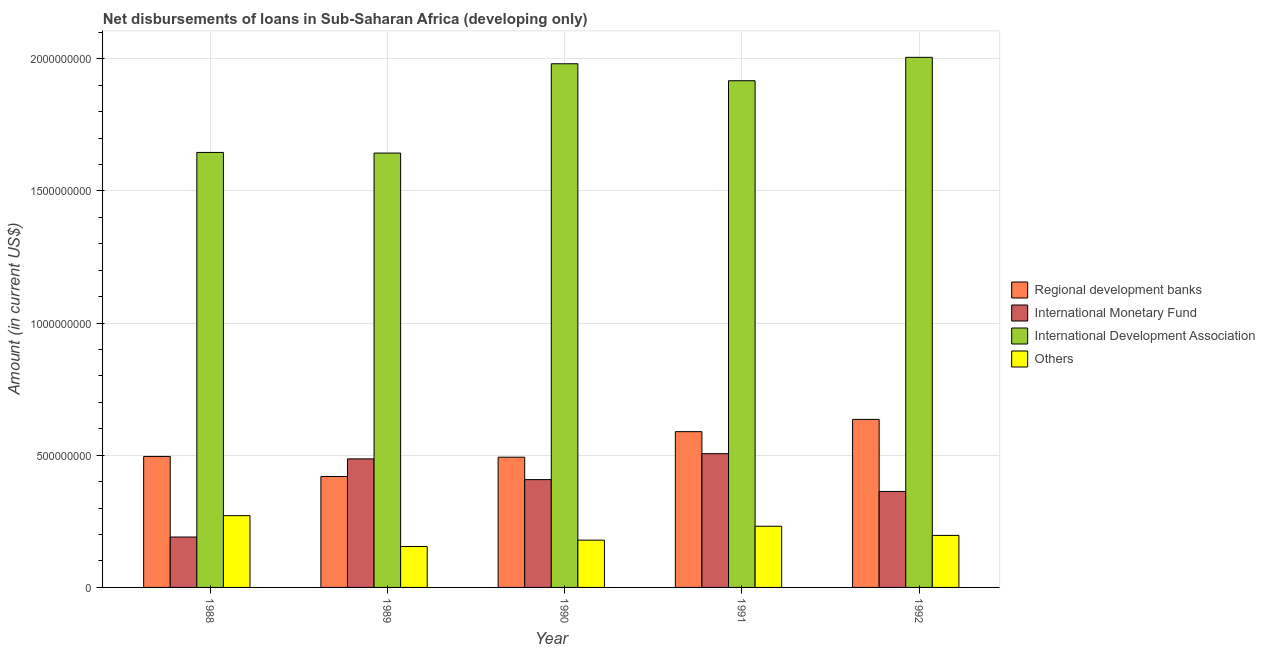How many different coloured bars are there?
Give a very brief answer. 4. How many groups of bars are there?
Give a very brief answer. 5. Are the number of bars per tick equal to the number of legend labels?
Provide a short and direct response. Yes. Are the number of bars on each tick of the X-axis equal?
Your response must be concise. Yes. How many bars are there on the 4th tick from the right?
Your response must be concise. 4. What is the label of the 4th group of bars from the left?
Your answer should be compact. 1991. What is the amount of loan disimbursed by international development association in 1989?
Offer a terse response. 1.64e+09. Across all years, what is the maximum amount of loan disimbursed by other organisations?
Your response must be concise. 2.72e+08. Across all years, what is the minimum amount of loan disimbursed by international monetary fund?
Your answer should be compact. 1.91e+08. In which year was the amount of loan disimbursed by international development association minimum?
Your response must be concise. 1989. What is the total amount of loan disimbursed by international development association in the graph?
Provide a short and direct response. 9.19e+09. What is the difference between the amount of loan disimbursed by international development association in 1989 and that in 1991?
Provide a short and direct response. -2.74e+08. What is the difference between the amount of loan disimbursed by international monetary fund in 1989 and the amount of loan disimbursed by regional development banks in 1988?
Give a very brief answer. 2.96e+08. What is the average amount of loan disimbursed by other organisations per year?
Offer a terse response. 2.07e+08. In how many years, is the amount of loan disimbursed by international development association greater than 600000000 US$?
Your response must be concise. 5. What is the ratio of the amount of loan disimbursed by international development association in 1989 to that in 1990?
Ensure brevity in your answer.  0.83. Is the amount of loan disimbursed by international development association in 1988 less than that in 1992?
Make the answer very short. Yes. Is the difference between the amount of loan disimbursed by regional development banks in 1990 and 1992 greater than the difference between the amount of loan disimbursed by international monetary fund in 1990 and 1992?
Keep it short and to the point. No. What is the difference between the highest and the second highest amount of loan disimbursed by regional development banks?
Provide a succinct answer. 4.63e+07. What is the difference between the highest and the lowest amount of loan disimbursed by regional development banks?
Ensure brevity in your answer.  2.16e+08. In how many years, is the amount of loan disimbursed by other organisations greater than the average amount of loan disimbursed by other organisations taken over all years?
Offer a very short reply. 2. Is it the case that in every year, the sum of the amount of loan disimbursed by international development association and amount of loan disimbursed by other organisations is greater than the sum of amount of loan disimbursed by international monetary fund and amount of loan disimbursed by regional development banks?
Give a very brief answer. Yes. What does the 3rd bar from the left in 1990 represents?
Make the answer very short. International Development Association. What does the 4th bar from the right in 1991 represents?
Your answer should be very brief. Regional development banks. Is it the case that in every year, the sum of the amount of loan disimbursed by regional development banks and amount of loan disimbursed by international monetary fund is greater than the amount of loan disimbursed by international development association?
Provide a succinct answer. No. How many bars are there?
Your answer should be very brief. 20. What is the difference between two consecutive major ticks on the Y-axis?
Keep it short and to the point. 5.00e+08. Does the graph contain any zero values?
Give a very brief answer. No. What is the title of the graph?
Offer a very short reply. Net disbursements of loans in Sub-Saharan Africa (developing only). What is the label or title of the X-axis?
Keep it short and to the point. Year. What is the label or title of the Y-axis?
Ensure brevity in your answer.  Amount (in current US$). What is the Amount (in current US$) in Regional development banks in 1988?
Provide a succinct answer. 4.96e+08. What is the Amount (in current US$) of International Monetary Fund in 1988?
Your answer should be compact. 1.91e+08. What is the Amount (in current US$) of International Development Association in 1988?
Offer a terse response. 1.65e+09. What is the Amount (in current US$) in Others in 1988?
Offer a very short reply. 2.72e+08. What is the Amount (in current US$) in Regional development banks in 1989?
Your response must be concise. 4.20e+08. What is the Amount (in current US$) of International Monetary Fund in 1989?
Offer a very short reply. 4.86e+08. What is the Amount (in current US$) in International Development Association in 1989?
Make the answer very short. 1.64e+09. What is the Amount (in current US$) in Others in 1989?
Ensure brevity in your answer.  1.55e+08. What is the Amount (in current US$) of Regional development banks in 1990?
Provide a succinct answer. 4.93e+08. What is the Amount (in current US$) of International Monetary Fund in 1990?
Provide a succinct answer. 4.08e+08. What is the Amount (in current US$) of International Development Association in 1990?
Ensure brevity in your answer.  1.98e+09. What is the Amount (in current US$) in Others in 1990?
Offer a very short reply. 1.79e+08. What is the Amount (in current US$) of Regional development banks in 1991?
Offer a terse response. 5.89e+08. What is the Amount (in current US$) in International Monetary Fund in 1991?
Ensure brevity in your answer.  5.06e+08. What is the Amount (in current US$) in International Development Association in 1991?
Your response must be concise. 1.92e+09. What is the Amount (in current US$) in Others in 1991?
Provide a short and direct response. 2.31e+08. What is the Amount (in current US$) of Regional development banks in 1992?
Give a very brief answer. 6.36e+08. What is the Amount (in current US$) in International Monetary Fund in 1992?
Offer a very short reply. 3.63e+08. What is the Amount (in current US$) in International Development Association in 1992?
Your answer should be very brief. 2.01e+09. What is the Amount (in current US$) of Others in 1992?
Ensure brevity in your answer.  1.97e+08. Across all years, what is the maximum Amount (in current US$) in Regional development banks?
Offer a terse response. 6.36e+08. Across all years, what is the maximum Amount (in current US$) of International Monetary Fund?
Provide a succinct answer. 5.06e+08. Across all years, what is the maximum Amount (in current US$) of International Development Association?
Your answer should be very brief. 2.01e+09. Across all years, what is the maximum Amount (in current US$) of Others?
Your response must be concise. 2.72e+08. Across all years, what is the minimum Amount (in current US$) of Regional development banks?
Ensure brevity in your answer.  4.20e+08. Across all years, what is the minimum Amount (in current US$) in International Monetary Fund?
Offer a terse response. 1.91e+08. Across all years, what is the minimum Amount (in current US$) of International Development Association?
Make the answer very short. 1.64e+09. Across all years, what is the minimum Amount (in current US$) in Others?
Provide a succinct answer. 1.55e+08. What is the total Amount (in current US$) in Regional development banks in the graph?
Your response must be concise. 2.63e+09. What is the total Amount (in current US$) of International Monetary Fund in the graph?
Give a very brief answer. 1.95e+09. What is the total Amount (in current US$) of International Development Association in the graph?
Keep it short and to the point. 9.19e+09. What is the total Amount (in current US$) of Others in the graph?
Your answer should be compact. 1.03e+09. What is the difference between the Amount (in current US$) of Regional development banks in 1988 and that in 1989?
Offer a terse response. 7.58e+07. What is the difference between the Amount (in current US$) of International Monetary Fund in 1988 and that in 1989?
Make the answer very short. -2.96e+08. What is the difference between the Amount (in current US$) in International Development Association in 1988 and that in 1989?
Offer a terse response. 2.42e+06. What is the difference between the Amount (in current US$) in Others in 1988 and that in 1989?
Keep it short and to the point. 1.17e+08. What is the difference between the Amount (in current US$) in Regional development banks in 1988 and that in 1990?
Your answer should be very brief. 2.80e+06. What is the difference between the Amount (in current US$) in International Monetary Fund in 1988 and that in 1990?
Give a very brief answer. -2.17e+08. What is the difference between the Amount (in current US$) of International Development Association in 1988 and that in 1990?
Offer a very short reply. -3.35e+08. What is the difference between the Amount (in current US$) in Others in 1988 and that in 1990?
Keep it short and to the point. 9.27e+07. What is the difference between the Amount (in current US$) of Regional development banks in 1988 and that in 1991?
Provide a succinct answer. -9.39e+07. What is the difference between the Amount (in current US$) of International Monetary Fund in 1988 and that in 1991?
Your answer should be very brief. -3.15e+08. What is the difference between the Amount (in current US$) in International Development Association in 1988 and that in 1991?
Give a very brief answer. -2.71e+08. What is the difference between the Amount (in current US$) of Others in 1988 and that in 1991?
Offer a terse response. 4.02e+07. What is the difference between the Amount (in current US$) of Regional development banks in 1988 and that in 1992?
Your answer should be very brief. -1.40e+08. What is the difference between the Amount (in current US$) in International Monetary Fund in 1988 and that in 1992?
Make the answer very short. -1.72e+08. What is the difference between the Amount (in current US$) in International Development Association in 1988 and that in 1992?
Your answer should be very brief. -3.60e+08. What is the difference between the Amount (in current US$) of Others in 1988 and that in 1992?
Offer a terse response. 7.48e+07. What is the difference between the Amount (in current US$) of Regional development banks in 1989 and that in 1990?
Offer a very short reply. -7.30e+07. What is the difference between the Amount (in current US$) of International Monetary Fund in 1989 and that in 1990?
Your answer should be very brief. 7.84e+07. What is the difference between the Amount (in current US$) of International Development Association in 1989 and that in 1990?
Your response must be concise. -3.38e+08. What is the difference between the Amount (in current US$) in Others in 1989 and that in 1990?
Provide a succinct answer. -2.41e+07. What is the difference between the Amount (in current US$) in Regional development banks in 1989 and that in 1991?
Offer a terse response. -1.70e+08. What is the difference between the Amount (in current US$) in International Monetary Fund in 1989 and that in 1991?
Provide a short and direct response. -1.97e+07. What is the difference between the Amount (in current US$) in International Development Association in 1989 and that in 1991?
Keep it short and to the point. -2.74e+08. What is the difference between the Amount (in current US$) in Others in 1989 and that in 1991?
Offer a terse response. -7.66e+07. What is the difference between the Amount (in current US$) of Regional development banks in 1989 and that in 1992?
Provide a succinct answer. -2.16e+08. What is the difference between the Amount (in current US$) in International Monetary Fund in 1989 and that in 1992?
Your response must be concise. 1.23e+08. What is the difference between the Amount (in current US$) of International Development Association in 1989 and that in 1992?
Your answer should be compact. -3.62e+08. What is the difference between the Amount (in current US$) of Others in 1989 and that in 1992?
Give a very brief answer. -4.20e+07. What is the difference between the Amount (in current US$) in Regional development banks in 1990 and that in 1991?
Offer a terse response. -9.66e+07. What is the difference between the Amount (in current US$) in International Monetary Fund in 1990 and that in 1991?
Ensure brevity in your answer.  -9.81e+07. What is the difference between the Amount (in current US$) of International Development Association in 1990 and that in 1991?
Keep it short and to the point. 6.42e+07. What is the difference between the Amount (in current US$) in Others in 1990 and that in 1991?
Your answer should be compact. -5.25e+07. What is the difference between the Amount (in current US$) of Regional development banks in 1990 and that in 1992?
Provide a succinct answer. -1.43e+08. What is the difference between the Amount (in current US$) in International Monetary Fund in 1990 and that in 1992?
Give a very brief answer. 4.48e+07. What is the difference between the Amount (in current US$) of International Development Association in 1990 and that in 1992?
Give a very brief answer. -2.44e+07. What is the difference between the Amount (in current US$) in Others in 1990 and that in 1992?
Provide a short and direct response. -1.79e+07. What is the difference between the Amount (in current US$) of Regional development banks in 1991 and that in 1992?
Your answer should be compact. -4.63e+07. What is the difference between the Amount (in current US$) in International Monetary Fund in 1991 and that in 1992?
Your answer should be compact. 1.43e+08. What is the difference between the Amount (in current US$) in International Development Association in 1991 and that in 1992?
Your answer should be very brief. -8.85e+07. What is the difference between the Amount (in current US$) in Others in 1991 and that in 1992?
Your response must be concise. 3.46e+07. What is the difference between the Amount (in current US$) in Regional development banks in 1988 and the Amount (in current US$) in International Monetary Fund in 1989?
Your answer should be very brief. 9.19e+06. What is the difference between the Amount (in current US$) of Regional development banks in 1988 and the Amount (in current US$) of International Development Association in 1989?
Keep it short and to the point. -1.15e+09. What is the difference between the Amount (in current US$) in Regional development banks in 1988 and the Amount (in current US$) in Others in 1989?
Offer a very short reply. 3.41e+08. What is the difference between the Amount (in current US$) in International Monetary Fund in 1988 and the Amount (in current US$) in International Development Association in 1989?
Give a very brief answer. -1.45e+09. What is the difference between the Amount (in current US$) of International Monetary Fund in 1988 and the Amount (in current US$) of Others in 1989?
Provide a succinct answer. 3.59e+07. What is the difference between the Amount (in current US$) in International Development Association in 1988 and the Amount (in current US$) in Others in 1989?
Ensure brevity in your answer.  1.49e+09. What is the difference between the Amount (in current US$) of Regional development banks in 1988 and the Amount (in current US$) of International Monetary Fund in 1990?
Ensure brevity in your answer.  8.76e+07. What is the difference between the Amount (in current US$) of Regional development banks in 1988 and the Amount (in current US$) of International Development Association in 1990?
Provide a short and direct response. -1.49e+09. What is the difference between the Amount (in current US$) in Regional development banks in 1988 and the Amount (in current US$) in Others in 1990?
Give a very brief answer. 3.17e+08. What is the difference between the Amount (in current US$) of International Monetary Fund in 1988 and the Amount (in current US$) of International Development Association in 1990?
Offer a terse response. -1.79e+09. What is the difference between the Amount (in current US$) in International Monetary Fund in 1988 and the Amount (in current US$) in Others in 1990?
Keep it short and to the point. 1.18e+07. What is the difference between the Amount (in current US$) in International Development Association in 1988 and the Amount (in current US$) in Others in 1990?
Your answer should be compact. 1.47e+09. What is the difference between the Amount (in current US$) of Regional development banks in 1988 and the Amount (in current US$) of International Monetary Fund in 1991?
Give a very brief answer. -1.05e+07. What is the difference between the Amount (in current US$) in Regional development banks in 1988 and the Amount (in current US$) in International Development Association in 1991?
Your answer should be compact. -1.42e+09. What is the difference between the Amount (in current US$) of Regional development banks in 1988 and the Amount (in current US$) of Others in 1991?
Your answer should be compact. 2.64e+08. What is the difference between the Amount (in current US$) in International Monetary Fund in 1988 and the Amount (in current US$) in International Development Association in 1991?
Offer a terse response. -1.73e+09. What is the difference between the Amount (in current US$) in International Monetary Fund in 1988 and the Amount (in current US$) in Others in 1991?
Provide a short and direct response. -4.08e+07. What is the difference between the Amount (in current US$) of International Development Association in 1988 and the Amount (in current US$) of Others in 1991?
Your answer should be compact. 1.41e+09. What is the difference between the Amount (in current US$) in Regional development banks in 1988 and the Amount (in current US$) in International Monetary Fund in 1992?
Your response must be concise. 1.32e+08. What is the difference between the Amount (in current US$) in Regional development banks in 1988 and the Amount (in current US$) in International Development Association in 1992?
Give a very brief answer. -1.51e+09. What is the difference between the Amount (in current US$) of Regional development banks in 1988 and the Amount (in current US$) of Others in 1992?
Your answer should be compact. 2.99e+08. What is the difference between the Amount (in current US$) in International Monetary Fund in 1988 and the Amount (in current US$) in International Development Association in 1992?
Offer a very short reply. -1.81e+09. What is the difference between the Amount (in current US$) in International Monetary Fund in 1988 and the Amount (in current US$) in Others in 1992?
Offer a terse response. -6.17e+06. What is the difference between the Amount (in current US$) of International Development Association in 1988 and the Amount (in current US$) of Others in 1992?
Offer a very short reply. 1.45e+09. What is the difference between the Amount (in current US$) of Regional development banks in 1989 and the Amount (in current US$) of International Monetary Fund in 1990?
Ensure brevity in your answer.  1.18e+07. What is the difference between the Amount (in current US$) in Regional development banks in 1989 and the Amount (in current US$) in International Development Association in 1990?
Your answer should be compact. -1.56e+09. What is the difference between the Amount (in current US$) in Regional development banks in 1989 and the Amount (in current US$) in Others in 1990?
Your answer should be compact. 2.41e+08. What is the difference between the Amount (in current US$) in International Monetary Fund in 1989 and the Amount (in current US$) in International Development Association in 1990?
Give a very brief answer. -1.49e+09. What is the difference between the Amount (in current US$) in International Monetary Fund in 1989 and the Amount (in current US$) in Others in 1990?
Provide a succinct answer. 3.07e+08. What is the difference between the Amount (in current US$) in International Development Association in 1989 and the Amount (in current US$) in Others in 1990?
Your answer should be very brief. 1.46e+09. What is the difference between the Amount (in current US$) of Regional development banks in 1989 and the Amount (in current US$) of International Monetary Fund in 1991?
Your answer should be very brief. -8.63e+07. What is the difference between the Amount (in current US$) of Regional development banks in 1989 and the Amount (in current US$) of International Development Association in 1991?
Keep it short and to the point. -1.50e+09. What is the difference between the Amount (in current US$) in Regional development banks in 1989 and the Amount (in current US$) in Others in 1991?
Ensure brevity in your answer.  1.88e+08. What is the difference between the Amount (in current US$) of International Monetary Fund in 1989 and the Amount (in current US$) of International Development Association in 1991?
Provide a succinct answer. -1.43e+09. What is the difference between the Amount (in current US$) of International Monetary Fund in 1989 and the Amount (in current US$) of Others in 1991?
Offer a terse response. 2.55e+08. What is the difference between the Amount (in current US$) of International Development Association in 1989 and the Amount (in current US$) of Others in 1991?
Give a very brief answer. 1.41e+09. What is the difference between the Amount (in current US$) in Regional development banks in 1989 and the Amount (in current US$) in International Monetary Fund in 1992?
Provide a short and direct response. 5.66e+07. What is the difference between the Amount (in current US$) of Regional development banks in 1989 and the Amount (in current US$) of International Development Association in 1992?
Your answer should be compact. -1.59e+09. What is the difference between the Amount (in current US$) in Regional development banks in 1989 and the Amount (in current US$) in Others in 1992?
Ensure brevity in your answer.  2.23e+08. What is the difference between the Amount (in current US$) in International Monetary Fund in 1989 and the Amount (in current US$) in International Development Association in 1992?
Offer a terse response. -1.52e+09. What is the difference between the Amount (in current US$) of International Monetary Fund in 1989 and the Amount (in current US$) of Others in 1992?
Your answer should be compact. 2.90e+08. What is the difference between the Amount (in current US$) in International Development Association in 1989 and the Amount (in current US$) in Others in 1992?
Give a very brief answer. 1.45e+09. What is the difference between the Amount (in current US$) in Regional development banks in 1990 and the Amount (in current US$) in International Monetary Fund in 1991?
Provide a succinct answer. -1.33e+07. What is the difference between the Amount (in current US$) in Regional development banks in 1990 and the Amount (in current US$) in International Development Association in 1991?
Offer a terse response. -1.42e+09. What is the difference between the Amount (in current US$) of Regional development banks in 1990 and the Amount (in current US$) of Others in 1991?
Make the answer very short. 2.61e+08. What is the difference between the Amount (in current US$) of International Monetary Fund in 1990 and the Amount (in current US$) of International Development Association in 1991?
Keep it short and to the point. -1.51e+09. What is the difference between the Amount (in current US$) of International Monetary Fund in 1990 and the Amount (in current US$) of Others in 1991?
Give a very brief answer. 1.76e+08. What is the difference between the Amount (in current US$) of International Development Association in 1990 and the Amount (in current US$) of Others in 1991?
Your answer should be compact. 1.75e+09. What is the difference between the Amount (in current US$) in Regional development banks in 1990 and the Amount (in current US$) in International Monetary Fund in 1992?
Ensure brevity in your answer.  1.30e+08. What is the difference between the Amount (in current US$) in Regional development banks in 1990 and the Amount (in current US$) in International Development Association in 1992?
Ensure brevity in your answer.  -1.51e+09. What is the difference between the Amount (in current US$) of Regional development banks in 1990 and the Amount (in current US$) of Others in 1992?
Ensure brevity in your answer.  2.96e+08. What is the difference between the Amount (in current US$) of International Monetary Fund in 1990 and the Amount (in current US$) of International Development Association in 1992?
Your answer should be very brief. -1.60e+09. What is the difference between the Amount (in current US$) in International Monetary Fund in 1990 and the Amount (in current US$) in Others in 1992?
Offer a terse response. 2.11e+08. What is the difference between the Amount (in current US$) of International Development Association in 1990 and the Amount (in current US$) of Others in 1992?
Offer a terse response. 1.78e+09. What is the difference between the Amount (in current US$) in Regional development banks in 1991 and the Amount (in current US$) in International Monetary Fund in 1992?
Your answer should be compact. 2.26e+08. What is the difference between the Amount (in current US$) in Regional development banks in 1991 and the Amount (in current US$) in International Development Association in 1992?
Offer a terse response. -1.42e+09. What is the difference between the Amount (in current US$) in Regional development banks in 1991 and the Amount (in current US$) in Others in 1992?
Your answer should be compact. 3.93e+08. What is the difference between the Amount (in current US$) of International Monetary Fund in 1991 and the Amount (in current US$) of International Development Association in 1992?
Give a very brief answer. -1.50e+09. What is the difference between the Amount (in current US$) in International Monetary Fund in 1991 and the Amount (in current US$) in Others in 1992?
Your response must be concise. 3.09e+08. What is the difference between the Amount (in current US$) of International Development Association in 1991 and the Amount (in current US$) of Others in 1992?
Ensure brevity in your answer.  1.72e+09. What is the average Amount (in current US$) in Regional development banks per year?
Provide a succinct answer. 5.27e+08. What is the average Amount (in current US$) in International Monetary Fund per year?
Provide a short and direct response. 3.91e+08. What is the average Amount (in current US$) of International Development Association per year?
Offer a terse response. 1.84e+09. What is the average Amount (in current US$) of Others per year?
Provide a short and direct response. 2.07e+08. In the year 1988, what is the difference between the Amount (in current US$) of Regional development banks and Amount (in current US$) of International Monetary Fund?
Give a very brief answer. 3.05e+08. In the year 1988, what is the difference between the Amount (in current US$) in Regional development banks and Amount (in current US$) in International Development Association?
Your answer should be compact. -1.15e+09. In the year 1988, what is the difference between the Amount (in current US$) of Regional development banks and Amount (in current US$) of Others?
Your answer should be very brief. 2.24e+08. In the year 1988, what is the difference between the Amount (in current US$) in International Monetary Fund and Amount (in current US$) in International Development Association?
Offer a very short reply. -1.46e+09. In the year 1988, what is the difference between the Amount (in current US$) of International Monetary Fund and Amount (in current US$) of Others?
Provide a succinct answer. -8.09e+07. In the year 1988, what is the difference between the Amount (in current US$) in International Development Association and Amount (in current US$) in Others?
Ensure brevity in your answer.  1.37e+09. In the year 1989, what is the difference between the Amount (in current US$) of Regional development banks and Amount (in current US$) of International Monetary Fund?
Provide a short and direct response. -6.66e+07. In the year 1989, what is the difference between the Amount (in current US$) in Regional development banks and Amount (in current US$) in International Development Association?
Your answer should be compact. -1.22e+09. In the year 1989, what is the difference between the Amount (in current US$) of Regional development banks and Amount (in current US$) of Others?
Offer a very short reply. 2.65e+08. In the year 1989, what is the difference between the Amount (in current US$) in International Monetary Fund and Amount (in current US$) in International Development Association?
Give a very brief answer. -1.16e+09. In the year 1989, what is the difference between the Amount (in current US$) of International Monetary Fund and Amount (in current US$) of Others?
Your answer should be compact. 3.32e+08. In the year 1989, what is the difference between the Amount (in current US$) in International Development Association and Amount (in current US$) in Others?
Offer a very short reply. 1.49e+09. In the year 1990, what is the difference between the Amount (in current US$) of Regional development banks and Amount (in current US$) of International Monetary Fund?
Give a very brief answer. 8.48e+07. In the year 1990, what is the difference between the Amount (in current US$) in Regional development banks and Amount (in current US$) in International Development Association?
Keep it short and to the point. -1.49e+09. In the year 1990, what is the difference between the Amount (in current US$) in Regional development banks and Amount (in current US$) in Others?
Your answer should be compact. 3.14e+08. In the year 1990, what is the difference between the Amount (in current US$) in International Monetary Fund and Amount (in current US$) in International Development Association?
Provide a succinct answer. -1.57e+09. In the year 1990, what is the difference between the Amount (in current US$) in International Monetary Fund and Amount (in current US$) in Others?
Keep it short and to the point. 2.29e+08. In the year 1990, what is the difference between the Amount (in current US$) in International Development Association and Amount (in current US$) in Others?
Ensure brevity in your answer.  1.80e+09. In the year 1991, what is the difference between the Amount (in current US$) of Regional development banks and Amount (in current US$) of International Monetary Fund?
Offer a terse response. 8.33e+07. In the year 1991, what is the difference between the Amount (in current US$) in Regional development banks and Amount (in current US$) in International Development Association?
Ensure brevity in your answer.  -1.33e+09. In the year 1991, what is the difference between the Amount (in current US$) of Regional development banks and Amount (in current US$) of Others?
Offer a very short reply. 3.58e+08. In the year 1991, what is the difference between the Amount (in current US$) in International Monetary Fund and Amount (in current US$) in International Development Association?
Ensure brevity in your answer.  -1.41e+09. In the year 1991, what is the difference between the Amount (in current US$) of International Monetary Fund and Amount (in current US$) of Others?
Ensure brevity in your answer.  2.75e+08. In the year 1991, what is the difference between the Amount (in current US$) of International Development Association and Amount (in current US$) of Others?
Make the answer very short. 1.69e+09. In the year 1992, what is the difference between the Amount (in current US$) of Regional development banks and Amount (in current US$) of International Monetary Fund?
Give a very brief answer. 2.73e+08. In the year 1992, what is the difference between the Amount (in current US$) of Regional development banks and Amount (in current US$) of International Development Association?
Your response must be concise. -1.37e+09. In the year 1992, what is the difference between the Amount (in current US$) in Regional development banks and Amount (in current US$) in Others?
Give a very brief answer. 4.39e+08. In the year 1992, what is the difference between the Amount (in current US$) in International Monetary Fund and Amount (in current US$) in International Development Association?
Your answer should be very brief. -1.64e+09. In the year 1992, what is the difference between the Amount (in current US$) in International Monetary Fund and Amount (in current US$) in Others?
Offer a terse response. 1.66e+08. In the year 1992, what is the difference between the Amount (in current US$) in International Development Association and Amount (in current US$) in Others?
Provide a short and direct response. 1.81e+09. What is the ratio of the Amount (in current US$) of Regional development banks in 1988 to that in 1989?
Offer a terse response. 1.18. What is the ratio of the Amount (in current US$) in International Monetary Fund in 1988 to that in 1989?
Keep it short and to the point. 0.39. What is the ratio of the Amount (in current US$) in International Development Association in 1988 to that in 1989?
Offer a terse response. 1. What is the ratio of the Amount (in current US$) in Others in 1988 to that in 1989?
Your response must be concise. 1.75. What is the ratio of the Amount (in current US$) in Regional development banks in 1988 to that in 1990?
Provide a short and direct response. 1.01. What is the ratio of the Amount (in current US$) of International Monetary Fund in 1988 to that in 1990?
Offer a terse response. 0.47. What is the ratio of the Amount (in current US$) in International Development Association in 1988 to that in 1990?
Offer a terse response. 0.83. What is the ratio of the Amount (in current US$) of Others in 1988 to that in 1990?
Ensure brevity in your answer.  1.52. What is the ratio of the Amount (in current US$) in Regional development banks in 1988 to that in 1991?
Provide a succinct answer. 0.84. What is the ratio of the Amount (in current US$) of International Monetary Fund in 1988 to that in 1991?
Offer a very short reply. 0.38. What is the ratio of the Amount (in current US$) in International Development Association in 1988 to that in 1991?
Ensure brevity in your answer.  0.86. What is the ratio of the Amount (in current US$) in Others in 1988 to that in 1991?
Offer a terse response. 1.17. What is the ratio of the Amount (in current US$) in Regional development banks in 1988 to that in 1992?
Offer a terse response. 0.78. What is the ratio of the Amount (in current US$) of International Monetary Fund in 1988 to that in 1992?
Your response must be concise. 0.53. What is the ratio of the Amount (in current US$) in International Development Association in 1988 to that in 1992?
Your answer should be compact. 0.82. What is the ratio of the Amount (in current US$) of Others in 1988 to that in 1992?
Your answer should be very brief. 1.38. What is the ratio of the Amount (in current US$) in Regional development banks in 1989 to that in 1990?
Offer a very short reply. 0.85. What is the ratio of the Amount (in current US$) in International Monetary Fund in 1989 to that in 1990?
Your answer should be very brief. 1.19. What is the ratio of the Amount (in current US$) in International Development Association in 1989 to that in 1990?
Provide a short and direct response. 0.83. What is the ratio of the Amount (in current US$) of Others in 1989 to that in 1990?
Offer a terse response. 0.87. What is the ratio of the Amount (in current US$) of Regional development banks in 1989 to that in 1991?
Keep it short and to the point. 0.71. What is the ratio of the Amount (in current US$) of International Monetary Fund in 1989 to that in 1991?
Give a very brief answer. 0.96. What is the ratio of the Amount (in current US$) of International Development Association in 1989 to that in 1991?
Provide a short and direct response. 0.86. What is the ratio of the Amount (in current US$) in Others in 1989 to that in 1991?
Your answer should be very brief. 0.67. What is the ratio of the Amount (in current US$) in Regional development banks in 1989 to that in 1992?
Make the answer very short. 0.66. What is the ratio of the Amount (in current US$) in International Monetary Fund in 1989 to that in 1992?
Your response must be concise. 1.34. What is the ratio of the Amount (in current US$) of International Development Association in 1989 to that in 1992?
Give a very brief answer. 0.82. What is the ratio of the Amount (in current US$) in Others in 1989 to that in 1992?
Provide a succinct answer. 0.79. What is the ratio of the Amount (in current US$) of Regional development banks in 1990 to that in 1991?
Give a very brief answer. 0.84. What is the ratio of the Amount (in current US$) in International Monetary Fund in 1990 to that in 1991?
Your answer should be very brief. 0.81. What is the ratio of the Amount (in current US$) of International Development Association in 1990 to that in 1991?
Your answer should be compact. 1.03. What is the ratio of the Amount (in current US$) of Others in 1990 to that in 1991?
Provide a succinct answer. 0.77. What is the ratio of the Amount (in current US$) of Regional development banks in 1990 to that in 1992?
Make the answer very short. 0.78. What is the ratio of the Amount (in current US$) in International Monetary Fund in 1990 to that in 1992?
Give a very brief answer. 1.12. What is the ratio of the Amount (in current US$) of International Development Association in 1990 to that in 1992?
Provide a short and direct response. 0.99. What is the ratio of the Amount (in current US$) of Others in 1990 to that in 1992?
Your answer should be very brief. 0.91. What is the ratio of the Amount (in current US$) in Regional development banks in 1991 to that in 1992?
Make the answer very short. 0.93. What is the ratio of the Amount (in current US$) of International Monetary Fund in 1991 to that in 1992?
Your answer should be very brief. 1.39. What is the ratio of the Amount (in current US$) in International Development Association in 1991 to that in 1992?
Keep it short and to the point. 0.96. What is the ratio of the Amount (in current US$) of Others in 1991 to that in 1992?
Give a very brief answer. 1.18. What is the difference between the highest and the second highest Amount (in current US$) in Regional development banks?
Keep it short and to the point. 4.63e+07. What is the difference between the highest and the second highest Amount (in current US$) of International Monetary Fund?
Offer a terse response. 1.97e+07. What is the difference between the highest and the second highest Amount (in current US$) of International Development Association?
Provide a short and direct response. 2.44e+07. What is the difference between the highest and the second highest Amount (in current US$) in Others?
Make the answer very short. 4.02e+07. What is the difference between the highest and the lowest Amount (in current US$) of Regional development banks?
Offer a very short reply. 2.16e+08. What is the difference between the highest and the lowest Amount (in current US$) of International Monetary Fund?
Provide a succinct answer. 3.15e+08. What is the difference between the highest and the lowest Amount (in current US$) in International Development Association?
Your answer should be compact. 3.62e+08. What is the difference between the highest and the lowest Amount (in current US$) of Others?
Ensure brevity in your answer.  1.17e+08. 